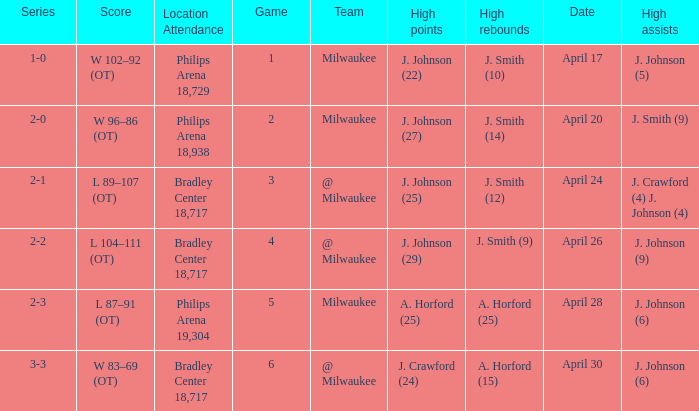What were the amount of rebounds in game 2? J. Smith (14). 